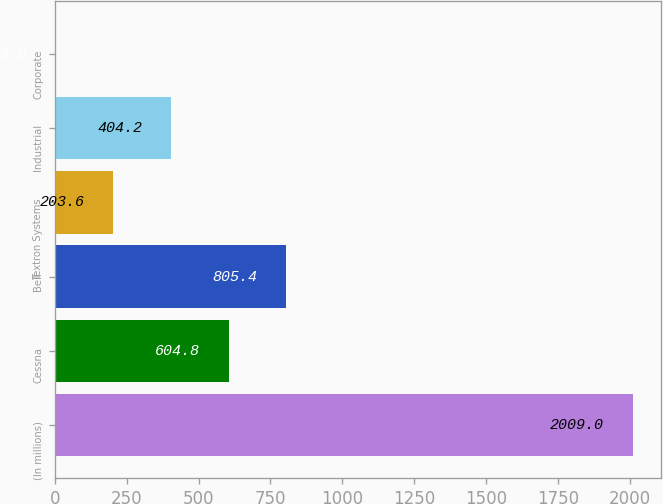Convert chart to OTSL. <chart><loc_0><loc_0><loc_500><loc_500><bar_chart><fcel>(In millions)<fcel>Cessna<fcel>Bell<fcel>Textron Systems<fcel>Industrial<fcel>Corporate<nl><fcel>2009<fcel>604.8<fcel>805.4<fcel>203.6<fcel>404.2<fcel>3<nl></chart> 